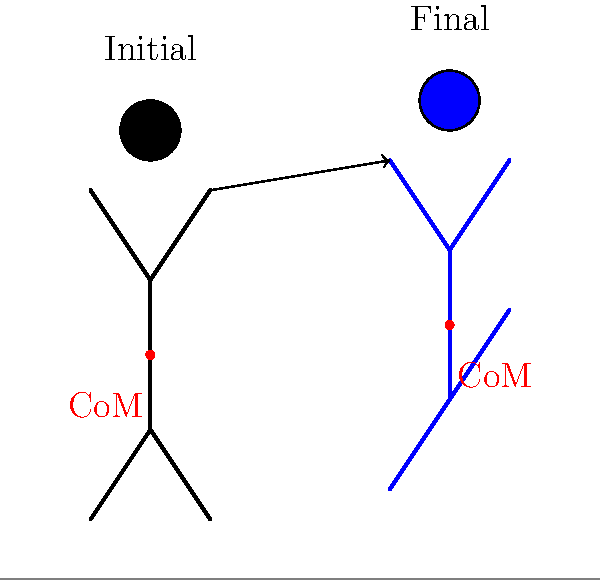During a running stride, how does the center of mass (CoM) of a runner typically shift, and what is the primary reason for this shift? To understand the shift in the center of mass during a running stride, let's break it down step-by-step:

1. Initial position: At the beginning of the stride, the runner's CoM is lower, as shown by the red dot on the black stick figure.

2. Final position: At the end of the stride, the runner's CoM is higher, as indicated by the red dot on the blue stick figure.

3. Vertical shift: The CoM moves upward from the initial to the final position. This vertical shift is crucial for efficient running.

4. Reason for the shift: The primary cause of this upward shift is the extension of the stance leg (the leg in contact with the ground) during the push-off phase of the stride.

5. Leg extension: As the runner pushes off the ground, they extend their hip, knee, and ankle joints. This extension creates an upward force that propels the body forward and upward.

6. Energy conversion: The upward shift of the CoM represents a conversion of kinetic energy to potential energy. This stored potential energy is then used in the next stride as the CoM falls back down.

7. Efficiency: This cyclical up-and-down movement of the CoM helps maintain forward momentum and contributes to the overall efficiency of the running gait.

8. Performance focus: For a performance-oriented athlete, understanding and optimizing this CoM shift can lead to improved running economy and speed.

The upward shift of the CoM during the stride is essential for efficient running mechanics and is directly related to the powerful extension of the stance leg during push-off.
Answer: Upward, due to stance leg extension during push-off. 